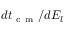<formula> <loc_0><loc_0><loc_500><loc_500>d t _ { c m } / d E _ { l }</formula> 